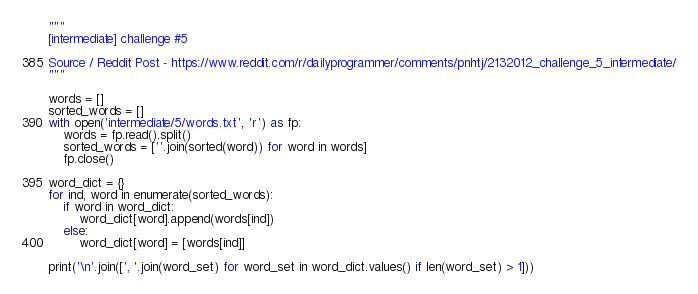<code> <loc_0><loc_0><loc_500><loc_500><_Python_>

"""
[intermediate] challenge #5

Source / Reddit Post - https://www.reddit.com/r/dailyprogrammer/comments/pnhtj/2132012_challenge_5_intermediate/
"""

words = []
sorted_words = []
with open('intermediate/5/words.txt', 'r') as fp:
    words = fp.read().split()
    sorted_words = [''.join(sorted(word)) for word in words]
    fp.close()

word_dict = {}
for ind, word in enumerate(sorted_words):
    if word in word_dict:
        word_dict[word].append(words[ind])
    else:
        word_dict[word] = [words[ind]]

print('\n'.join([', '.join(word_set) for word_set in word_dict.values() if len(word_set) > 1]))
</code> 